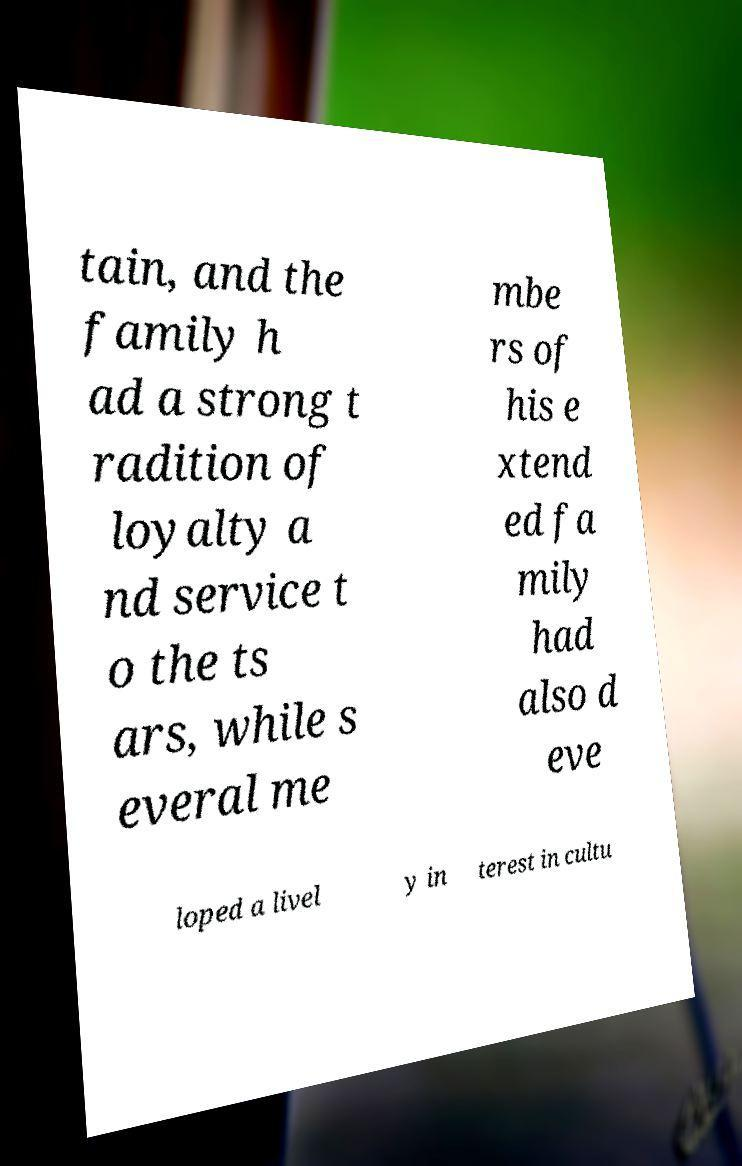I need the written content from this picture converted into text. Can you do that? tain, and the family h ad a strong t radition of loyalty a nd service t o the ts ars, while s everal me mbe rs of his e xtend ed fa mily had also d eve loped a livel y in terest in cultu 